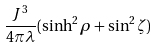Convert formula to latex. <formula><loc_0><loc_0><loc_500><loc_500>\frac { J ^ { 3 } } { 4 \pi \lambda } ( \sinh ^ { 2 } \rho + \sin ^ { 2 } \zeta )</formula> 